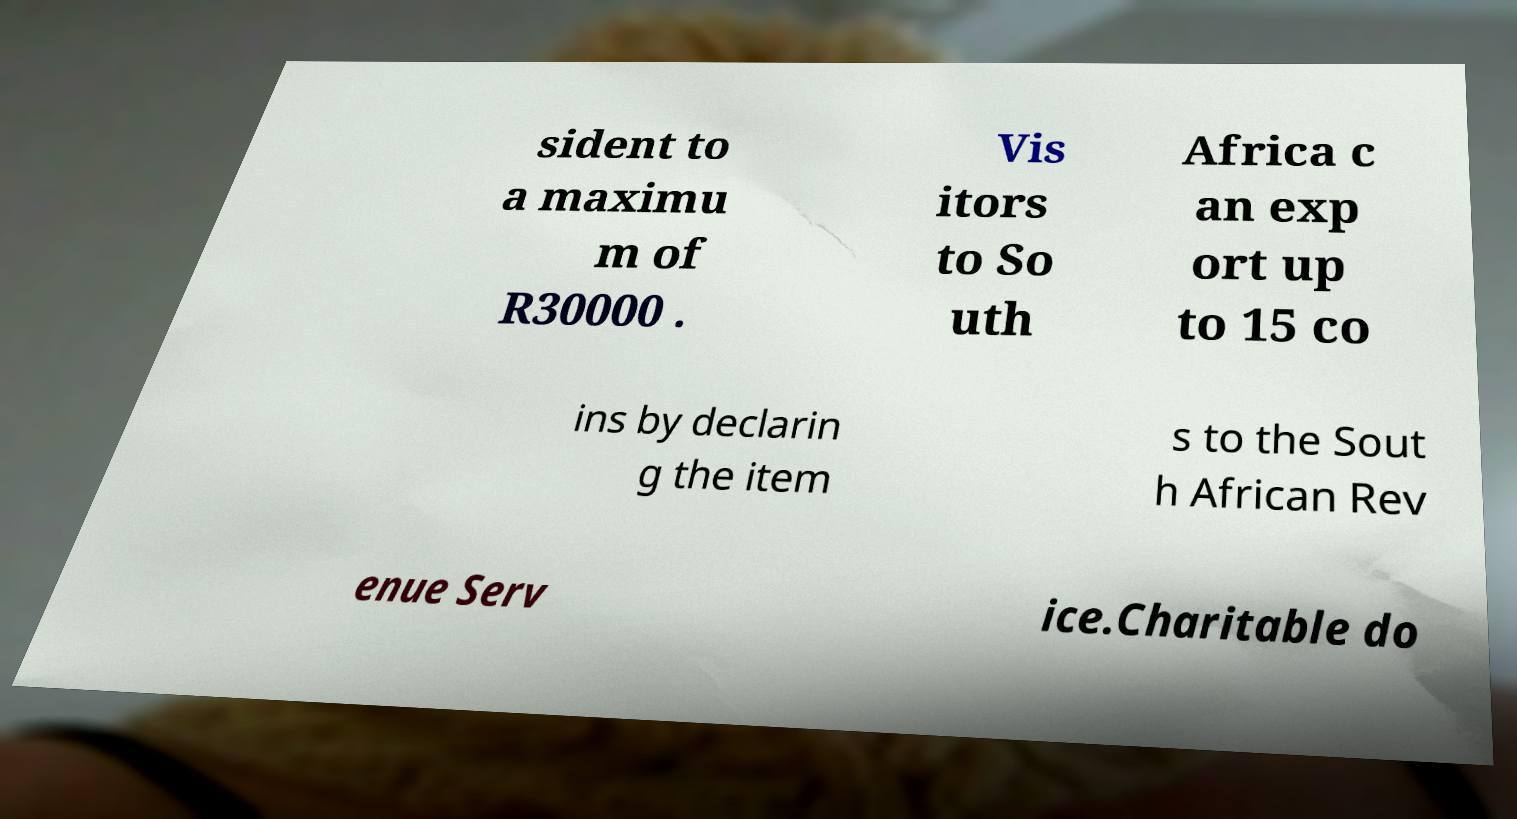There's text embedded in this image that I need extracted. Can you transcribe it verbatim? sident to a maximu m of R30000 . Vis itors to So uth Africa c an exp ort up to 15 co ins by declarin g the item s to the Sout h African Rev enue Serv ice.Charitable do 